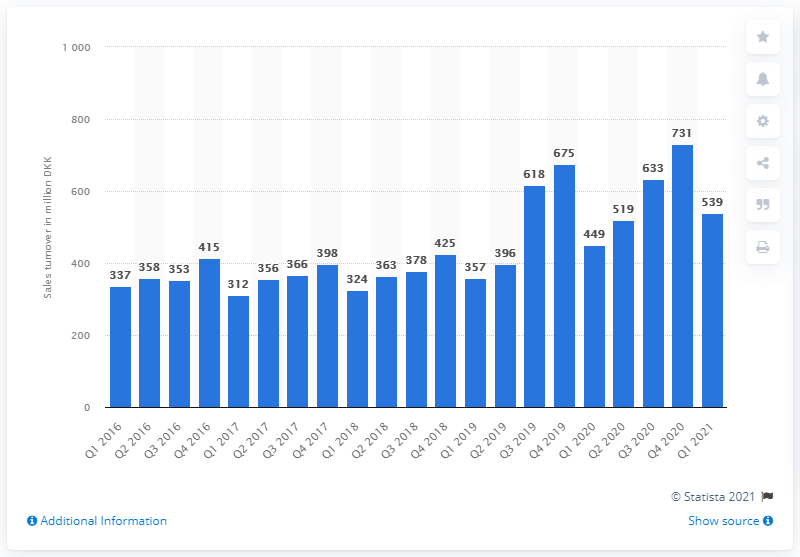Mention a couple of crucial points in this snapshot. In the last quarter of 2020, the sales turnover of baby articles and children's clothing in Denmark was 731 million Danish kroner. In the first quarter of 2021, the sales turnover of baby articles and children's clothing in Denmark was 539 million Danish kroner. 